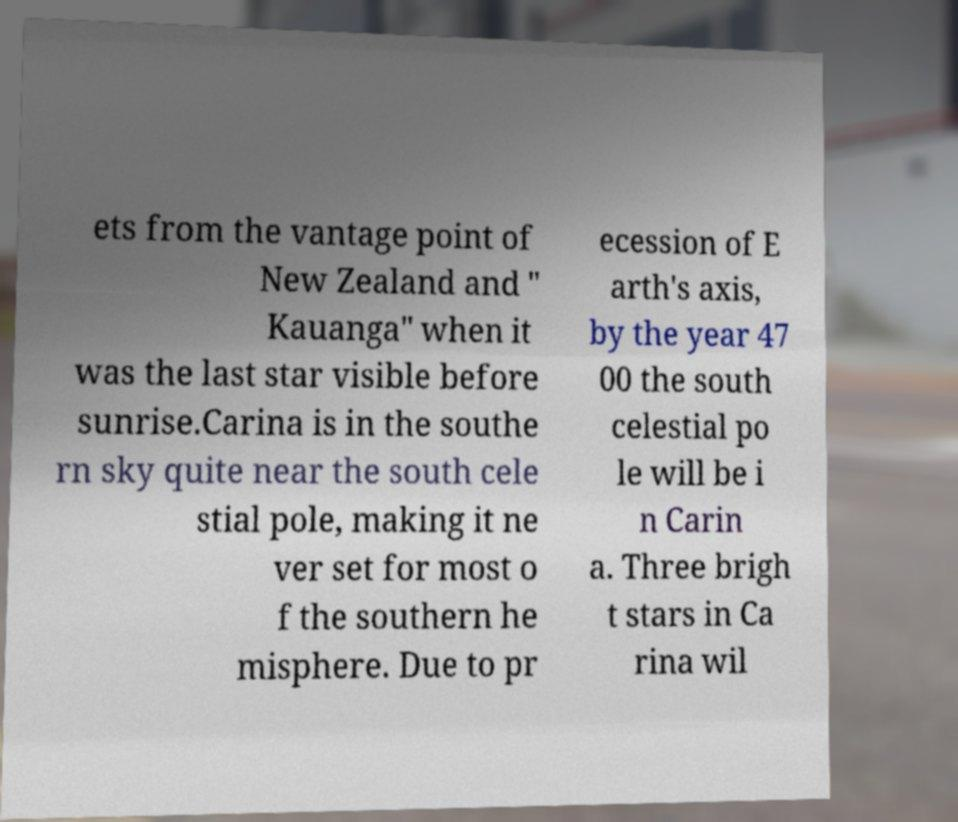There's text embedded in this image that I need extracted. Can you transcribe it verbatim? ets from the vantage point of New Zealand and " Kauanga" when it was the last star visible before sunrise.Carina is in the southe rn sky quite near the south cele stial pole, making it ne ver set for most o f the southern he misphere. Due to pr ecession of E arth's axis, by the year 47 00 the south celestial po le will be i n Carin a. Three brigh t stars in Ca rina wil 